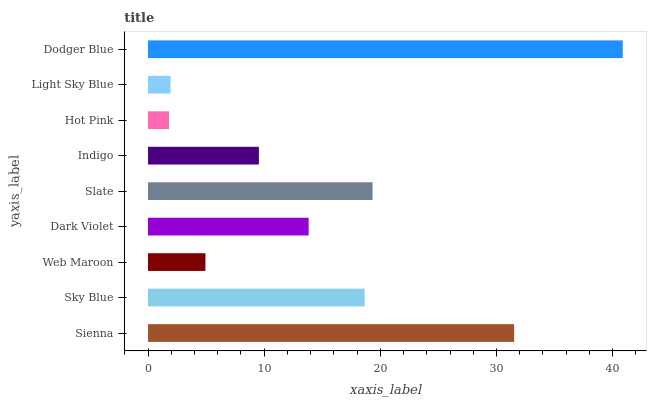Is Hot Pink the minimum?
Answer yes or no. Yes. Is Dodger Blue the maximum?
Answer yes or no. Yes. Is Sky Blue the minimum?
Answer yes or no. No. Is Sky Blue the maximum?
Answer yes or no. No. Is Sienna greater than Sky Blue?
Answer yes or no. Yes. Is Sky Blue less than Sienna?
Answer yes or no. Yes. Is Sky Blue greater than Sienna?
Answer yes or no. No. Is Sienna less than Sky Blue?
Answer yes or no. No. Is Dark Violet the high median?
Answer yes or no. Yes. Is Dark Violet the low median?
Answer yes or no. Yes. Is Sky Blue the high median?
Answer yes or no. No. Is Hot Pink the low median?
Answer yes or no. No. 